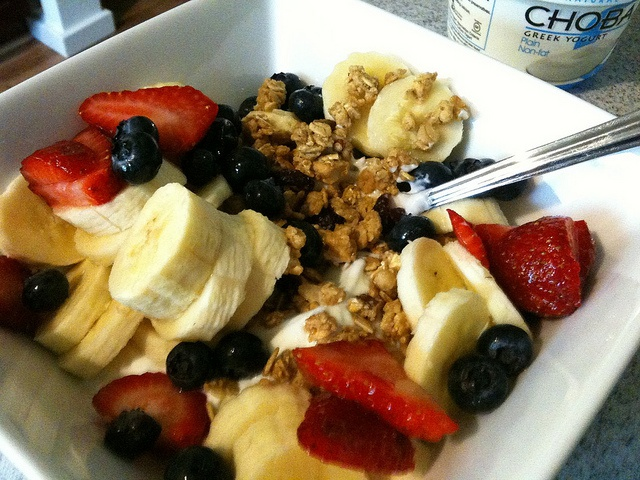Describe the objects in this image and their specific colors. I can see bowl in black, ivory, maroon, and olive tones, banana in black, tan, khaki, and lightyellow tones, banana in black, tan, olive, and maroon tones, banana in black, khaki, tan, and olive tones, and spoon in black, white, darkgray, and gray tones in this image. 